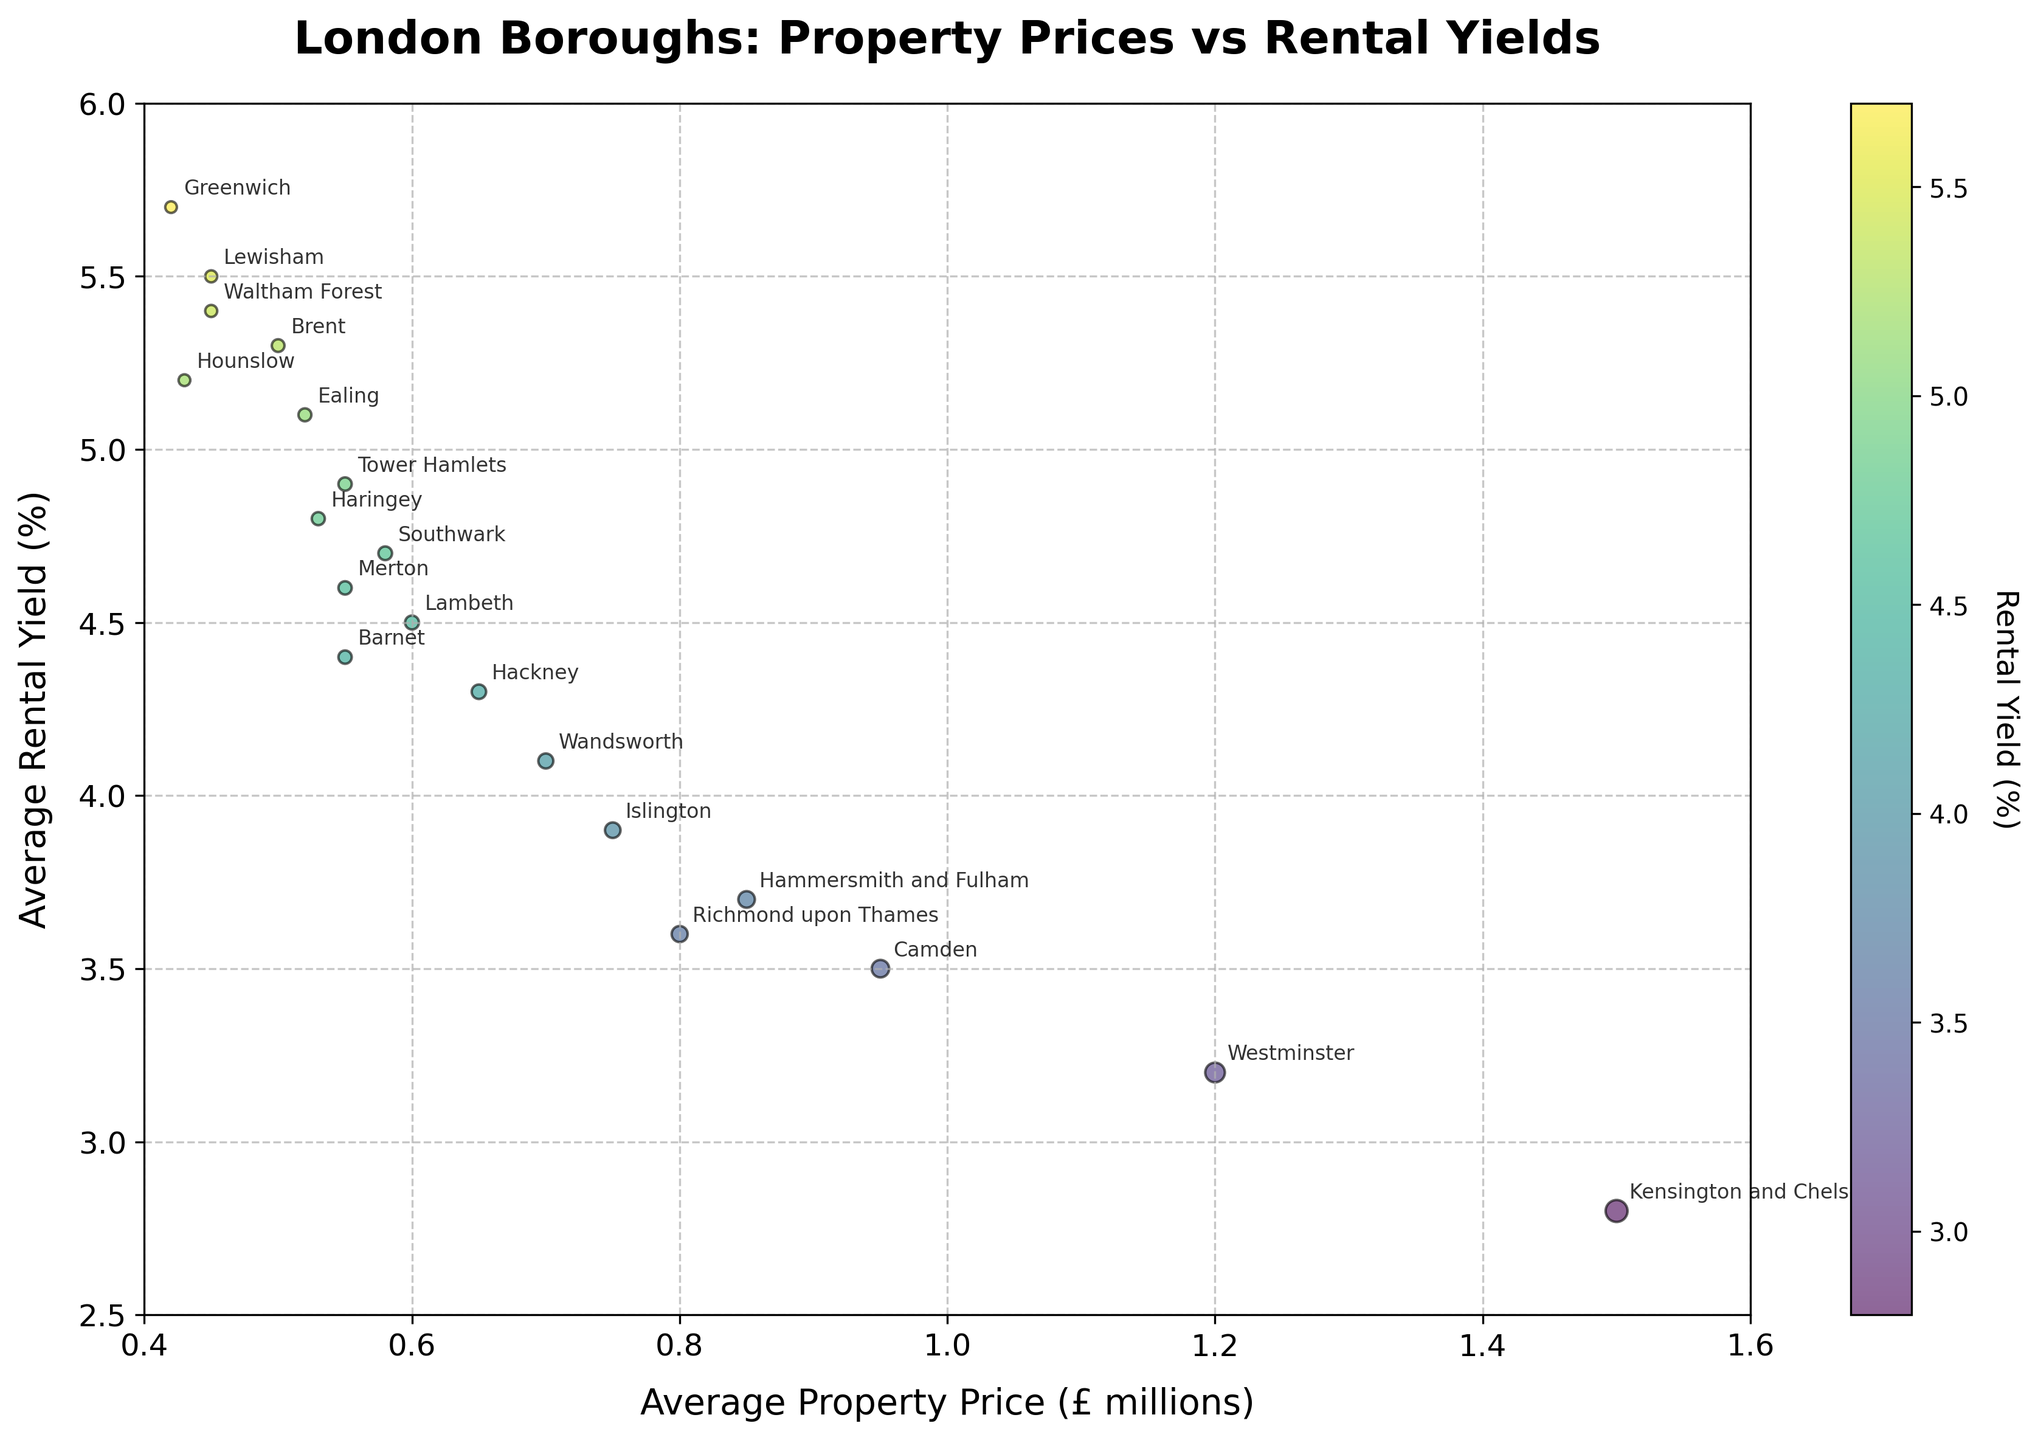What's the title of the figure? The title is usually displayed at the top of the plot in a larger font size. In this case, the title is "London Boroughs: Property Prices vs Rental Yields".
Answer: London Boroughs: Property Prices vs Rental Yields Which borough has the highest average property price? To determine this, look at the horizontal (x-axis) values for the points. The farthest point to the right represents the highest property price. According to the data, this is Kensington and Chelsea.
Answer: Kensington and Chelsea What's the average rental yield in Tower Hamlets? Locate Tower Hamlets on the plot and note its position on the y-axis. From the data, the average rental yield for Tower Hamlets is 4.9%.
Answer: 4.9% How are the points colored in the scatter plot? Points are colored according to the average rental yield, displayed using a color gradient (viridis). This is shown in the colorbar with darker tones representing lower yields and brighter tones higher yields.
Answer: By rental yield Which borough has the smallest bubble size, and what does that represent? Bubble size represents average property price. The smallest bubbles are located furthest to the left. According to the plot, the smallest bubble is for Greenwich, representing the lowest property price of £420,000.
Answer: Greenwich How many boroughs have an average rental yield of 5% or higher? Look at the points on the plot that lie on or above the 5% mark on the y-axis: Ealing, Brent, Lewisham, Greenwich, Waltham Forest, and Hounslow. Count these to get the total number.
Answer: Six Which borough has the lowest rental yield and what’s its average property price? Look at the lowest point on the y-axis, which represents the rental yield. The borough with the lowest yield is Kensington and Chelsea with a rental yield of 2.8%. Its average property price is £1,500,000.
Answer: Kensington and Chelsea, £1,500,000 Compare the rental yield and property price between Lambeth and Camden. Locate Lambeth and Camden on the plot. Lambeth has a lower average property price of £600,000 and a higher rental yield of 4.5%, while Camden has a higher average property price of £950,000 and a lower rental yield of 3.5%.
Answer: Lambeth: 4.5%, £600,000; Camden: 3.5%, £950,000 Which borough has the highest rental yield and how does that correlate with its property price? The borough with the highest rental yield can be found at the topmost point on the y-axis. According to the plot, this is Greenwich with a rental yield of 5.7%. Its property price is relatively low at £420,000.
Answer: Greenwich, £420,000 